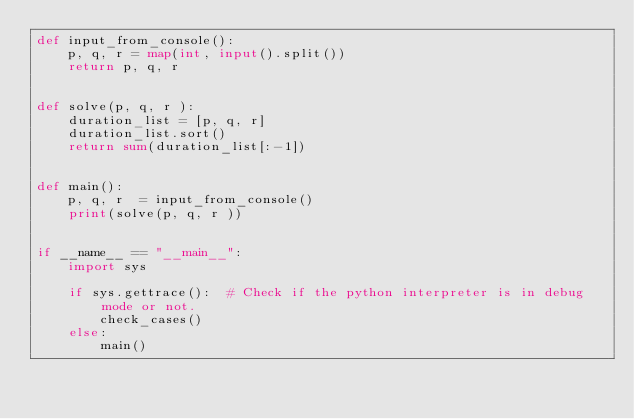<code> <loc_0><loc_0><loc_500><loc_500><_Python_>def input_from_console():
    p, q, r = map(int, input().split())
    return p, q, r


def solve(p, q, r ):
    duration_list = [p, q, r]
    duration_list.sort()
    return sum(duration_list[:-1])


def main():
    p, q, r  = input_from_console()
    print(solve(p, q, r ))


if __name__ == "__main__":
    import sys

    if sys.gettrace():  # Check if the python interpreter is in debug mode or not.
        check_cases()
    else:
        main()
</code> 